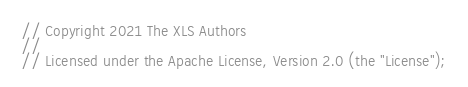<code> <loc_0><loc_0><loc_500><loc_500><_C_>// Copyright 2021 The XLS Authors
//
// Licensed under the Apache License, Version 2.0 (the "License");</code> 